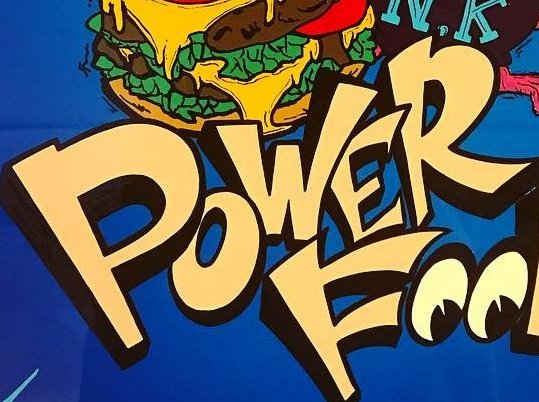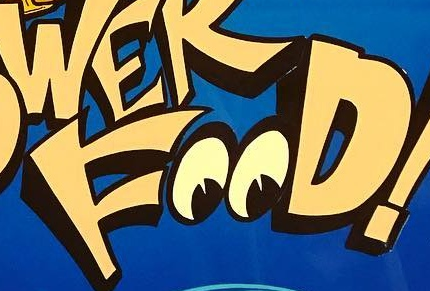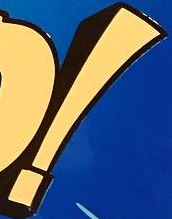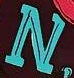Identify the words shown in these images in order, separated by a semicolon. POWER; FOOD; !; N 